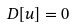<formula> <loc_0><loc_0><loc_500><loc_500>D [ u ] = 0</formula> 